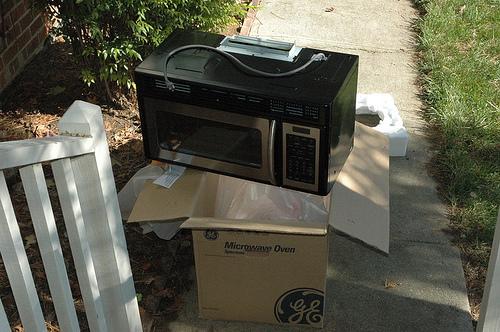What is on the ground behind the box?
Keep it brief. Styrofoam. What was inside the box?
Write a very short answer. Microwave. What brand microwave is this?
Short answer required. Ge. 